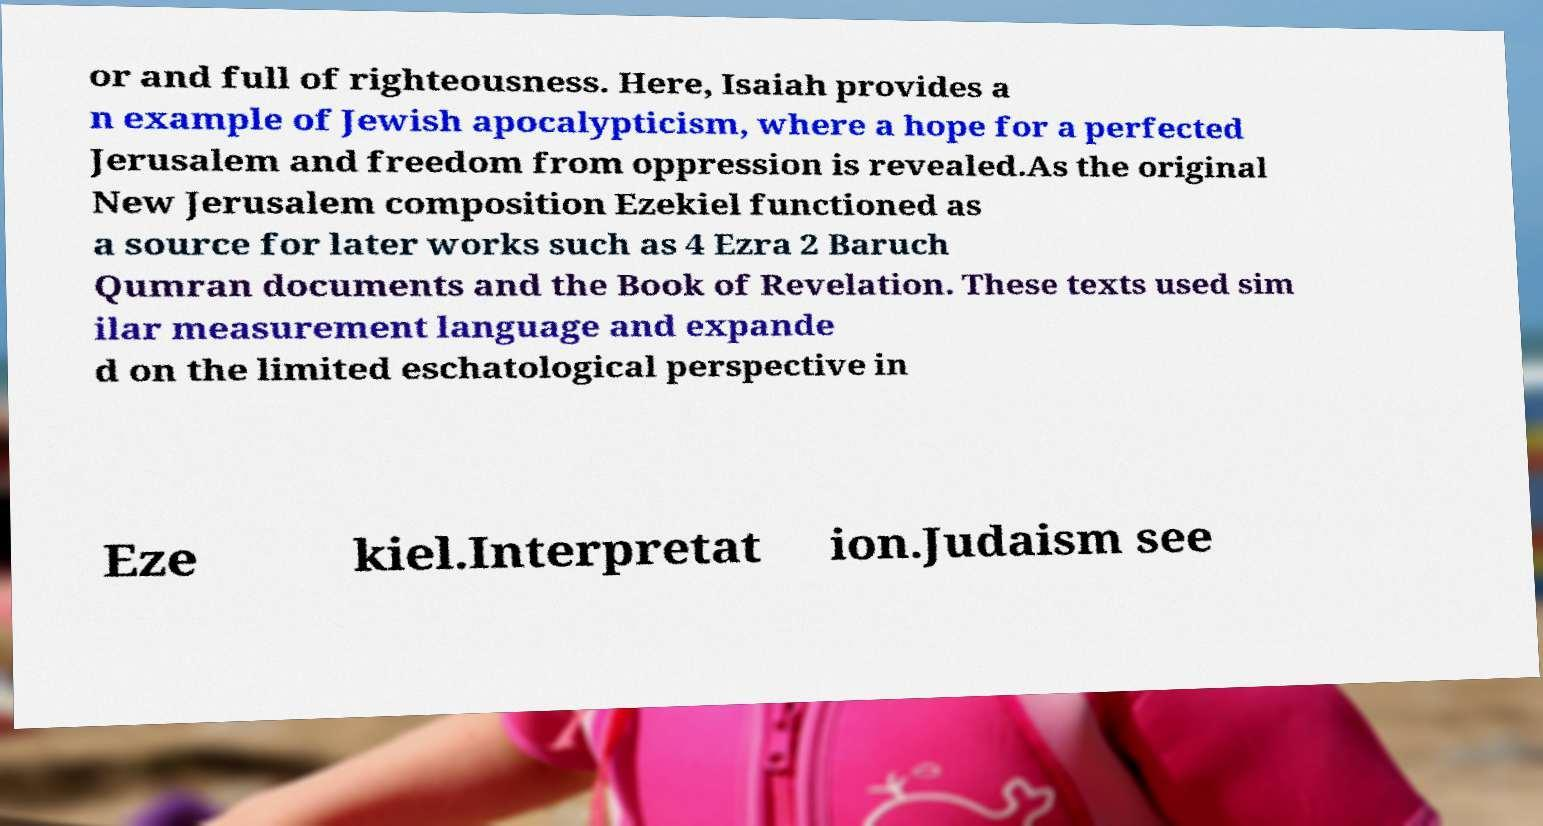Please identify and transcribe the text found in this image. or and full of righteousness. Here, Isaiah provides a n example of Jewish apocalypticism, where a hope for a perfected Jerusalem and freedom from oppression is revealed.As the original New Jerusalem composition Ezekiel functioned as a source for later works such as 4 Ezra 2 Baruch Qumran documents and the Book of Revelation. These texts used sim ilar measurement language and expande d on the limited eschatological perspective in Eze kiel.Interpretat ion.Judaism see 